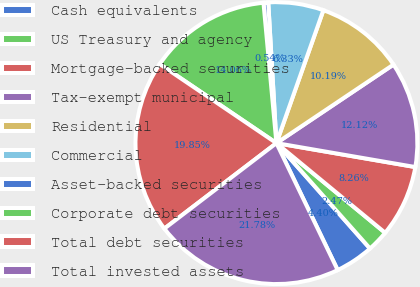Convert chart. <chart><loc_0><loc_0><loc_500><loc_500><pie_chart><fcel>Cash equivalents<fcel>US Treasury and agency<fcel>Mortgage-backed securities<fcel>Tax-exempt municipal<fcel>Residential<fcel>Commercial<fcel>Asset-backed securities<fcel>Corporate debt securities<fcel>Total debt securities<fcel>Total invested assets<nl><fcel>4.4%<fcel>2.47%<fcel>8.26%<fcel>12.12%<fcel>10.19%<fcel>6.33%<fcel>0.54%<fcel>14.06%<fcel>19.85%<fcel>21.78%<nl></chart> 